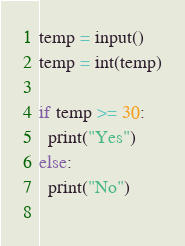<code> <loc_0><loc_0><loc_500><loc_500><_Python_>temp = input()
temp = int(temp)

if temp >= 30:
  print("Yes")
else:
  print("No")
    </code> 